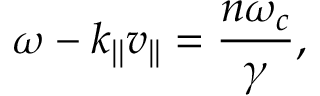Convert formula to latex. <formula><loc_0><loc_0><loc_500><loc_500>\omega - k _ { | | } v _ { | | } = \frac { n \omega _ { c } } { \gamma } ,</formula> 